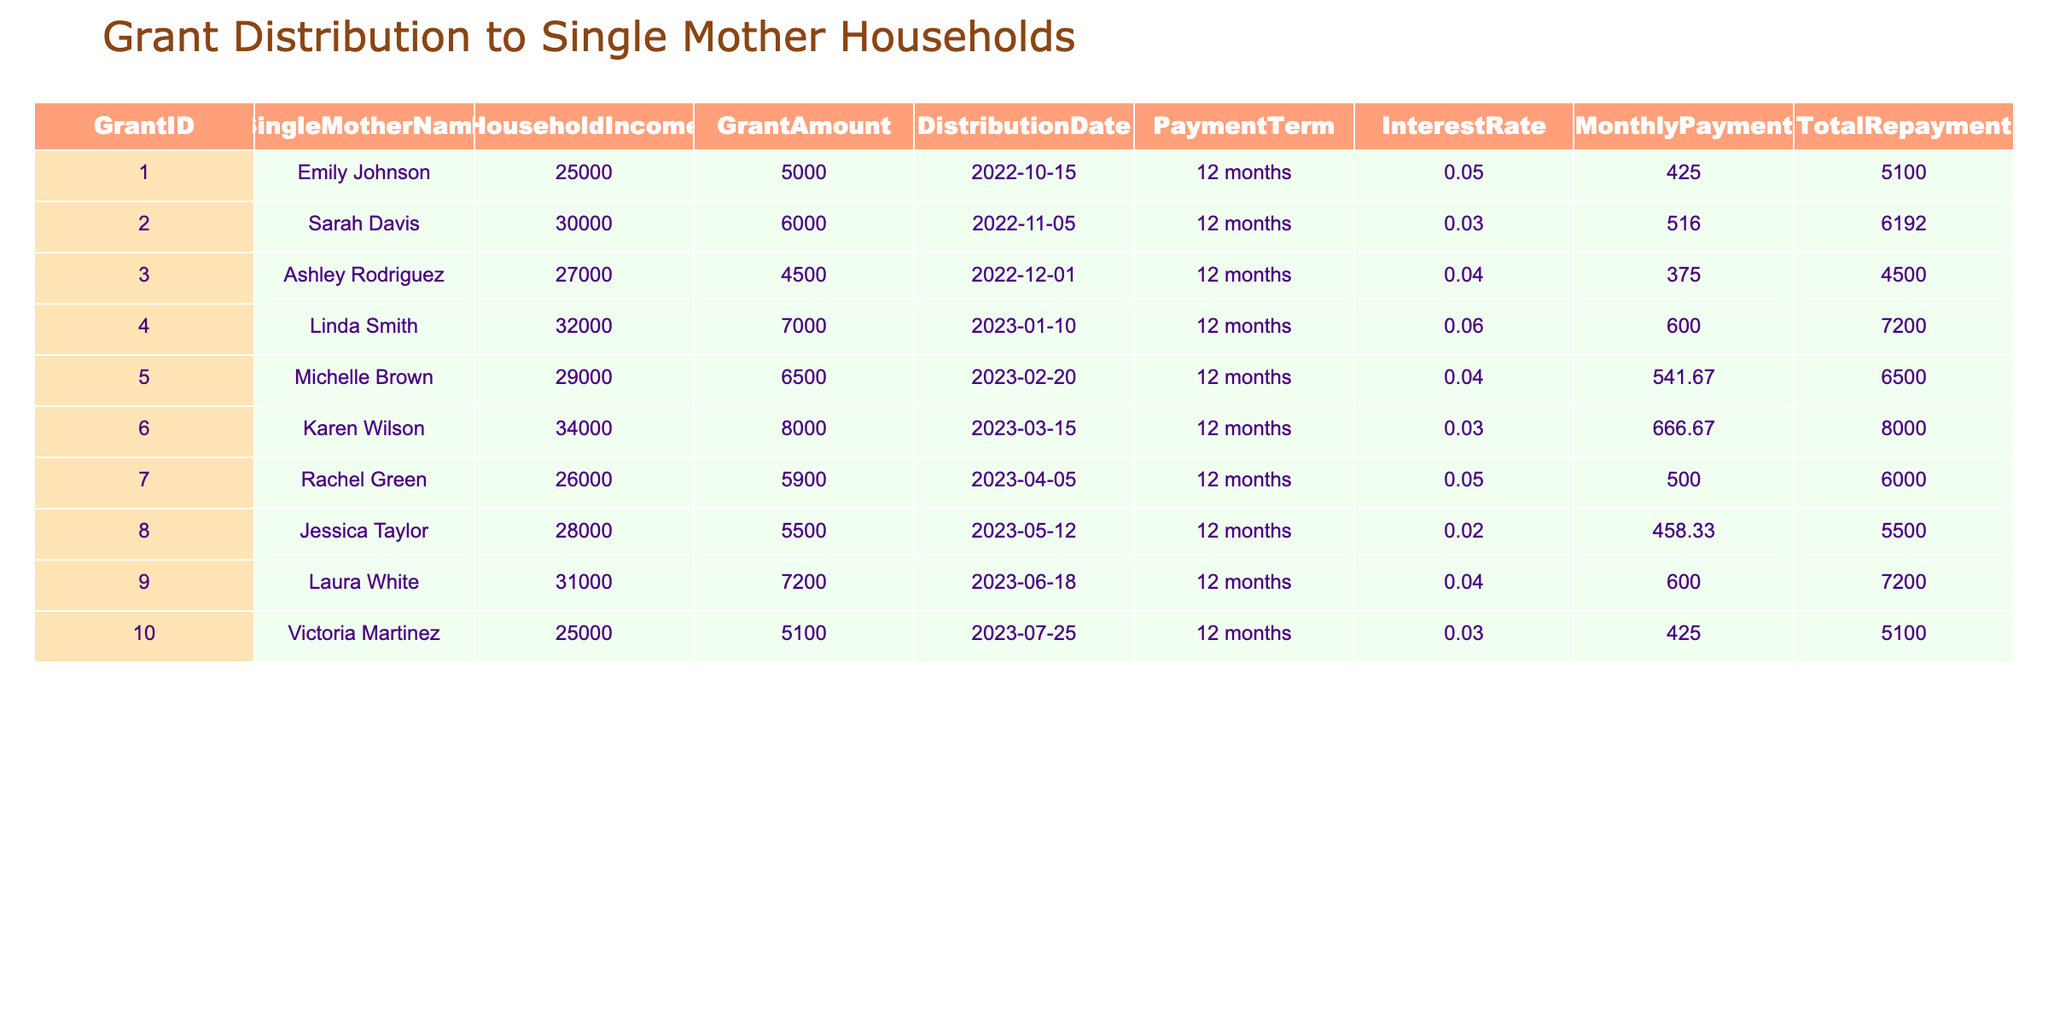What is the total amount of grants distributed? To find the total amount of grants distributed, we sum the 'Grant Amount' column. The amounts are: 5000, 6000, 4500, 7000, 6500, 8000, 5900, 5500, 7200, 5100. Adding these together gives 5000 + 6000 + 4500 + 7000 + 6500 + 8000 + 5900 + 5500 + 7200 + 5100 = 66300.
Answer: 66300 Who received the highest grant amount? Looking at the 'Grant Amount' column, the maximum value is 8000, which corresponds to Karen Wilson.
Answer: Karen Wilson How many single mothers received grants in total? Counting the number of unique entries in the 'SingleMotherName' column, there are 10 different names listed, indicating that 10 single mothers received grants.
Answer: 10 What is the average monthly payment across all grants? To find the average monthly payment, we first sum all values in the 'Monthly Payment' column: 425.00 + 516.00 + 375.00 + 600.00 + 541.67 + 666.67 + 500.00 + 458.33 + 600.00 + 425.00 = 4313.67. Then, divide by the number of entries (10) to get the average: 4313.67 / 10 = 431.37.
Answer: 431.37 Is there any single mother with an interest rate lower than 0.03? Looking in the 'Interest Rate' column, the lowest value is 0.02 (Jessica Taylor), which is indeed lower than 0.03.
Answer: Yes What is the total repayment required for Linda Smith? The total repayment for Linda Smith is listed directly in the 'Total Repayment' column. For her, it is 7200.
Answer: 7200 What is the difference between the highest and lowest grant amounts? The highest grant amount is 8000 (for Karen Wilson) and the lowest is 4500 (for Ashley Rodriguez). The difference is calculated as 8000 - 4500 = 3500.
Answer: 3500 Which single mother has the lowest household income? Examining the 'Household Income' column, the lowest value is 25000, which corresponds to both Emily Johnson and Victoria Martinez.
Answer: Emily Johnson and Victoria Martinez What is the total repayment for all grant recipients? The total repayment is calculated by summing the 'Total Repayment' column: 5100 + 6192 + 4500 + 7200 + 6500 + 8000 + 6000 + 5500 + 7200 + 5100 = 57392.
Answer: 57392 